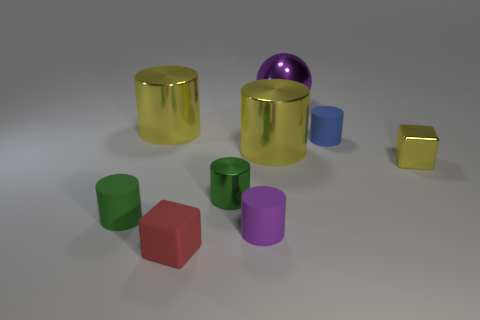Do the tiny rubber thing that is to the left of the red object and the small block behind the red thing have the same color?
Your answer should be compact. No. Are there more blocks that are behind the small purple matte cylinder than big cyan cylinders?
Your response must be concise. Yes. What material is the red block?
Offer a very short reply. Rubber. What is the shape of the red object that is the same material as the tiny blue cylinder?
Keep it short and to the point. Cube. What size is the yellow metallic cylinder that is right of the cube left of the tiny shiny cylinder?
Make the answer very short. Large. What is the color of the rubber cylinder that is to the left of the tiny metal cylinder?
Keep it short and to the point. Green. Are there any other small yellow things of the same shape as the small yellow thing?
Ensure brevity in your answer.  No. Are there fewer things that are behind the purple shiny ball than blue things that are behind the tiny blue object?
Ensure brevity in your answer.  No. The matte cube has what color?
Your response must be concise. Red. There is a tiny yellow shiny object right of the large metallic sphere; are there any small green matte cylinders that are to the right of it?
Keep it short and to the point. No. 